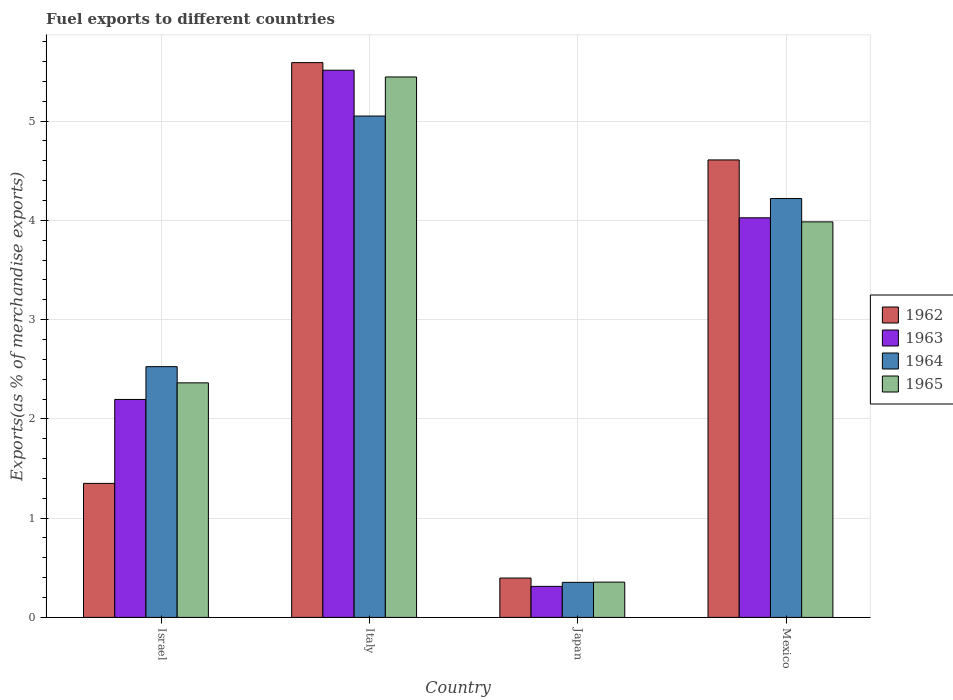Are the number of bars per tick equal to the number of legend labels?
Give a very brief answer. Yes. Are the number of bars on each tick of the X-axis equal?
Offer a very short reply. Yes. How many bars are there on the 1st tick from the left?
Provide a succinct answer. 4. How many bars are there on the 1st tick from the right?
Your answer should be compact. 4. What is the label of the 2nd group of bars from the left?
Give a very brief answer. Italy. What is the percentage of exports to different countries in 1964 in Italy?
Provide a short and direct response. 5.05. Across all countries, what is the maximum percentage of exports to different countries in 1965?
Your answer should be very brief. 5.45. Across all countries, what is the minimum percentage of exports to different countries in 1964?
Keep it short and to the point. 0.35. In which country was the percentage of exports to different countries in 1964 maximum?
Offer a terse response. Italy. In which country was the percentage of exports to different countries in 1963 minimum?
Provide a short and direct response. Japan. What is the total percentage of exports to different countries in 1964 in the graph?
Your response must be concise. 12.15. What is the difference between the percentage of exports to different countries in 1964 in Japan and that in Mexico?
Your response must be concise. -3.87. What is the difference between the percentage of exports to different countries in 1963 in Japan and the percentage of exports to different countries in 1962 in Italy?
Provide a succinct answer. -5.28. What is the average percentage of exports to different countries in 1962 per country?
Make the answer very short. 2.99. What is the difference between the percentage of exports to different countries of/in 1964 and percentage of exports to different countries of/in 1963 in Italy?
Provide a succinct answer. -0.46. What is the ratio of the percentage of exports to different countries in 1964 in Italy to that in Mexico?
Give a very brief answer. 1.2. Is the percentage of exports to different countries in 1963 in Italy less than that in Japan?
Your response must be concise. No. Is the difference between the percentage of exports to different countries in 1964 in Israel and Italy greater than the difference between the percentage of exports to different countries in 1963 in Israel and Italy?
Give a very brief answer. Yes. What is the difference between the highest and the second highest percentage of exports to different countries in 1962?
Your response must be concise. -3.26. What is the difference between the highest and the lowest percentage of exports to different countries in 1965?
Provide a short and direct response. 5.09. Is the sum of the percentage of exports to different countries in 1963 in Israel and Mexico greater than the maximum percentage of exports to different countries in 1962 across all countries?
Make the answer very short. Yes. What does the 2nd bar from the right in Japan represents?
Your response must be concise. 1964. Is it the case that in every country, the sum of the percentage of exports to different countries in 1963 and percentage of exports to different countries in 1962 is greater than the percentage of exports to different countries in 1965?
Give a very brief answer. Yes. Are the values on the major ticks of Y-axis written in scientific E-notation?
Provide a short and direct response. No. Does the graph contain grids?
Provide a succinct answer. Yes. Where does the legend appear in the graph?
Give a very brief answer. Center right. How many legend labels are there?
Your answer should be very brief. 4. How are the legend labels stacked?
Offer a terse response. Vertical. What is the title of the graph?
Offer a terse response. Fuel exports to different countries. Does "1977" appear as one of the legend labels in the graph?
Make the answer very short. No. What is the label or title of the Y-axis?
Make the answer very short. Exports(as % of merchandise exports). What is the Exports(as % of merchandise exports) of 1962 in Israel?
Your response must be concise. 1.35. What is the Exports(as % of merchandise exports) of 1963 in Israel?
Your answer should be compact. 2.2. What is the Exports(as % of merchandise exports) of 1964 in Israel?
Your answer should be very brief. 2.53. What is the Exports(as % of merchandise exports) of 1965 in Israel?
Your answer should be very brief. 2.36. What is the Exports(as % of merchandise exports) in 1962 in Italy?
Provide a succinct answer. 5.59. What is the Exports(as % of merchandise exports) in 1963 in Italy?
Make the answer very short. 5.51. What is the Exports(as % of merchandise exports) in 1964 in Italy?
Make the answer very short. 5.05. What is the Exports(as % of merchandise exports) in 1965 in Italy?
Give a very brief answer. 5.45. What is the Exports(as % of merchandise exports) of 1962 in Japan?
Keep it short and to the point. 0.4. What is the Exports(as % of merchandise exports) of 1963 in Japan?
Ensure brevity in your answer.  0.31. What is the Exports(as % of merchandise exports) of 1964 in Japan?
Make the answer very short. 0.35. What is the Exports(as % of merchandise exports) of 1965 in Japan?
Your answer should be compact. 0.36. What is the Exports(as % of merchandise exports) of 1962 in Mexico?
Give a very brief answer. 4.61. What is the Exports(as % of merchandise exports) of 1963 in Mexico?
Keep it short and to the point. 4.03. What is the Exports(as % of merchandise exports) of 1964 in Mexico?
Offer a very short reply. 4.22. What is the Exports(as % of merchandise exports) of 1965 in Mexico?
Ensure brevity in your answer.  3.99. Across all countries, what is the maximum Exports(as % of merchandise exports) in 1962?
Your response must be concise. 5.59. Across all countries, what is the maximum Exports(as % of merchandise exports) of 1963?
Offer a terse response. 5.51. Across all countries, what is the maximum Exports(as % of merchandise exports) of 1964?
Provide a short and direct response. 5.05. Across all countries, what is the maximum Exports(as % of merchandise exports) in 1965?
Provide a succinct answer. 5.45. Across all countries, what is the minimum Exports(as % of merchandise exports) in 1962?
Your answer should be very brief. 0.4. Across all countries, what is the minimum Exports(as % of merchandise exports) of 1963?
Provide a short and direct response. 0.31. Across all countries, what is the minimum Exports(as % of merchandise exports) of 1964?
Make the answer very short. 0.35. Across all countries, what is the minimum Exports(as % of merchandise exports) of 1965?
Offer a terse response. 0.36. What is the total Exports(as % of merchandise exports) in 1962 in the graph?
Make the answer very short. 11.95. What is the total Exports(as % of merchandise exports) in 1963 in the graph?
Give a very brief answer. 12.05. What is the total Exports(as % of merchandise exports) of 1964 in the graph?
Provide a short and direct response. 12.15. What is the total Exports(as % of merchandise exports) of 1965 in the graph?
Give a very brief answer. 12.15. What is the difference between the Exports(as % of merchandise exports) of 1962 in Israel and that in Italy?
Your answer should be very brief. -4.24. What is the difference between the Exports(as % of merchandise exports) in 1963 in Israel and that in Italy?
Make the answer very short. -3.32. What is the difference between the Exports(as % of merchandise exports) in 1964 in Israel and that in Italy?
Keep it short and to the point. -2.53. What is the difference between the Exports(as % of merchandise exports) in 1965 in Israel and that in Italy?
Ensure brevity in your answer.  -3.08. What is the difference between the Exports(as % of merchandise exports) of 1962 in Israel and that in Japan?
Your response must be concise. 0.95. What is the difference between the Exports(as % of merchandise exports) of 1963 in Israel and that in Japan?
Offer a terse response. 1.88. What is the difference between the Exports(as % of merchandise exports) of 1964 in Israel and that in Japan?
Your answer should be compact. 2.17. What is the difference between the Exports(as % of merchandise exports) of 1965 in Israel and that in Japan?
Your answer should be very brief. 2.01. What is the difference between the Exports(as % of merchandise exports) in 1962 in Israel and that in Mexico?
Ensure brevity in your answer.  -3.26. What is the difference between the Exports(as % of merchandise exports) of 1963 in Israel and that in Mexico?
Your answer should be compact. -1.83. What is the difference between the Exports(as % of merchandise exports) in 1964 in Israel and that in Mexico?
Give a very brief answer. -1.69. What is the difference between the Exports(as % of merchandise exports) in 1965 in Israel and that in Mexico?
Provide a short and direct response. -1.62. What is the difference between the Exports(as % of merchandise exports) in 1962 in Italy and that in Japan?
Make the answer very short. 5.19. What is the difference between the Exports(as % of merchandise exports) of 1963 in Italy and that in Japan?
Your answer should be compact. 5.2. What is the difference between the Exports(as % of merchandise exports) in 1964 in Italy and that in Japan?
Make the answer very short. 4.7. What is the difference between the Exports(as % of merchandise exports) of 1965 in Italy and that in Japan?
Your answer should be very brief. 5.09. What is the difference between the Exports(as % of merchandise exports) in 1962 in Italy and that in Mexico?
Offer a very short reply. 0.98. What is the difference between the Exports(as % of merchandise exports) in 1963 in Italy and that in Mexico?
Provide a short and direct response. 1.49. What is the difference between the Exports(as % of merchandise exports) in 1964 in Italy and that in Mexico?
Ensure brevity in your answer.  0.83. What is the difference between the Exports(as % of merchandise exports) in 1965 in Italy and that in Mexico?
Give a very brief answer. 1.46. What is the difference between the Exports(as % of merchandise exports) of 1962 in Japan and that in Mexico?
Provide a succinct answer. -4.21. What is the difference between the Exports(as % of merchandise exports) in 1963 in Japan and that in Mexico?
Offer a terse response. -3.71. What is the difference between the Exports(as % of merchandise exports) of 1964 in Japan and that in Mexico?
Your answer should be very brief. -3.87. What is the difference between the Exports(as % of merchandise exports) of 1965 in Japan and that in Mexico?
Keep it short and to the point. -3.63. What is the difference between the Exports(as % of merchandise exports) in 1962 in Israel and the Exports(as % of merchandise exports) in 1963 in Italy?
Offer a very short reply. -4.16. What is the difference between the Exports(as % of merchandise exports) of 1962 in Israel and the Exports(as % of merchandise exports) of 1964 in Italy?
Your answer should be compact. -3.7. What is the difference between the Exports(as % of merchandise exports) of 1962 in Israel and the Exports(as % of merchandise exports) of 1965 in Italy?
Provide a short and direct response. -4.09. What is the difference between the Exports(as % of merchandise exports) of 1963 in Israel and the Exports(as % of merchandise exports) of 1964 in Italy?
Offer a terse response. -2.86. What is the difference between the Exports(as % of merchandise exports) of 1963 in Israel and the Exports(as % of merchandise exports) of 1965 in Italy?
Your answer should be very brief. -3.25. What is the difference between the Exports(as % of merchandise exports) of 1964 in Israel and the Exports(as % of merchandise exports) of 1965 in Italy?
Your answer should be compact. -2.92. What is the difference between the Exports(as % of merchandise exports) of 1962 in Israel and the Exports(as % of merchandise exports) of 1963 in Japan?
Offer a terse response. 1.04. What is the difference between the Exports(as % of merchandise exports) in 1962 in Israel and the Exports(as % of merchandise exports) in 1964 in Japan?
Offer a very short reply. 1. What is the difference between the Exports(as % of merchandise exports) of 1962 in Israel and the Exports(as % of merchandise exports) of 1965 in Japan?
Give a very brief answer. 0.99. What is the difference between the Exports(as % of merchandise exports) in 1963 in Israel and the Exports(as % of merchandise exports) in 1964 in Japan?
Offer a very short reply. 1.84. What is the difference between the Exports(as % of merchandise exports) in 1963 in Israel and the Exports(as % of merchandise exports) in 1965 in Japan?
Give a very brief answer. 1.84. What is the difference between the Exports(as % of merchandise exports) in 1964 in Israel and the Exports(as % of merchandise exports) in 1965 in Japan?
Your answer should be compact. 2.17. What is the difference between the Exports(as % of merchandise exports) in 1962 in Israel and the Exports(as % of merchandise exports) in 1963 in Mexico?
Your answer should be very brief. -2.68. What is the difference between the Exports(as % of merchandise exports) in 1962 in Israel and the Exports(as % of merchandise exports) in 1964 in Mexico?
Make the answer very short. -2.87. What is the difference between the Exports(as % of merchandise exports) in 1962 in Israel and the Exports(as % of merchandise exports) in 1965 in Mexico?
Provide a short and direct response. -2.63. What is the difference between the Exports(as % of merchandise exports) of 1963 in Israel and the Exports(as % of merchandise exports) of 1964 in Mexico?
Your answer should be very brief. -2.02. What is the difference between the Exports(as % of merchandise exports) of 1963 in Israel and the Exports(as % of merchandise exports) of 1965 in Mexico?
Your answer should be very brief. -1.79. What is the difference between the Exports(as % of merchandise exports) in 1964 in Israel and the Exports(as % of merchandise exports) in 1965 in Mexico?
Your response must be concise. -1.46. What is the difference between the Exports(as % of merchandise exports) in 1962 in Italy and the Exports(as % of merchandise exports) in 1963 in Japan?
Provide a succinct answer. 5.28. What is the difference between the Exports(as % of merchandise exports) of 1962 in Italy and the Exports(as % of merchandise exports) of 1964 in Japan?
Your response must be concise. 5.24. What is the difference between the Exports(as % of merchandise exports) in 1962 in Italy and the Exports(as % of merchandise exports) in 1965 in Japan?
Offer a very short reply. 5.23. What is the difference between the Exports(as % of merchandise exports) of 1963 in Italy and the Exports(as % of merchandise exports) of 1964 in Japan?
Provide a short and direct response. 5.16. What is the difference between the Exports(as % of merchandise exports) in 1963 in Italy and the Exports(as % of merchandise exports) in 1965 in Japan?
Give a very brief answer. 5.16. What is the difference between the Exports(as % of merchandise exports) in 1964 in Italy and the Exports(as % of merchandise exports) in 1965 in Japan?
Ensure brevity in your answer.  4.7. What is the difference between the Exports(as % of merchandise exports) in 1962 in Italy and the Exports(as % of merchandise exports) in 1963 in Mexico?
Offer a terse response. 1.56. What is the difference between the Exports(as % of merchandise exports) in 1962 in Italy and the Exports(as % of merchandise exports) in 1964 in Mexico?
Your answer should be very brief. 1.37. What is the difference between the Exports(as % of merchandise exports) of 1962 in Italy and the Exports(as % of merchandise exports) of 1965 in Mexico?
Ensure brevity in your answer.  1.6. What is the difference between the Exports(as % of merchandise exports) of 1963 in Italy and the Exports(as % of merchandise exports) of 1964 in Mexico?
Provide a succinct answer. 1.29. What is the difference between the Exports(as % of merchandise exports) of 1963 in Italy and the Exports(as % of merchandise exports) of 1965 in Mexico?
Provide a short and direct response. 1.53. What is the difference between the Exports(as % of merchandise exports) in 1964 in Italy and the Exports(as % of merchandise exports) in 1965 in Mexico?
Give a very brief answer. 1.07. What is the difference between the Exports(as % of merchandise exports) in 1962 in Japan and the Exports(as % of merchandise exports) in 1963 in Mexico?
Offer a very short reply. -3.63. What is the difference between the Exports(as % of merchandise exports) of 1962 in Japan and the Exports(as % of merchandise exports) of 1964 in Mexico?
Your response must be concise. -3.82. What is the difference between the Exports(as % of merchandise exports) in 1962 in Japan and the Exports(as % of merchandise exports) in 1965 in Mexico?
Offer a terse response. -3.59. What is the difference between the Exports(as % of merchandise exports) of 1963 in Japan and the Exports(as % of merchandise exports) of 1964 in Mexico?
Provide a short and direct response. -3.91. What is the difference between the Exports(as % of merchandise exports) of 1963 in Japan and the Exports(as % of merchandise exports) of 1965 in Mexico?
Your answer should be very brief. -3.67. What is the difference between the Exports(as % of merchandise exports) of 1964 in Japan and the Exports(as % of merchandise exports) of 1965 in Mexico?
Provide a short and direct response. -3.63. What is the average Exports(as % of merchandise exports) in 1962 per country?
Ensure brevity in your answer.  2.99. What is the average Exports(as % of merchandise exports) of 1963 per country?
Make the answer very short. 3.01. What is the average Exports(as % of merchandise exports) of 1964 per country?
Your answer should be compact. 3.04. What is the average Exports(as % of merchandise exports) of 1965 per country?
Your answer should be very brief. 3.04. What is the difference between the Exports(as % of merchandise exports) of 1962 and Exports(as % of merchandise exports) of 1963 in Israel?
Offer a very short reply. -0.85. What is the difference between the Exports(as % of merchandise exports) of 1962 and Exports(as % of merchandise exports) of 1964 in Israel?
Provide a short and direct response. -1.18. What is the difference between the Exports(as % of merchandise exports) in 1962 and Exports(as % of merchandise exports) in 1965 in Israel?
Offer a terse response. -1.01. What is the difference between the Exports(as % of merchandise exports) in 1963 and Exports(as % of merchandise exports) in 1964 in Israel?
Provide a short and direct response. -0.33. What is the difference between the Exports(as % of merchandise exports) in 1963 and Exports(as % of merchandise exports) in 1965 in Israel?
Keep it short and to the point. -0.17. What is the difference between the Exports(as % of merchandise exports) in 1964 and Exports(as % of merchandise exports) in 1965 in Israel?
Ensure brevity in your answer.  0.16. What is the difference between the Exports(as % of merchandise exports) in 1962 and Exports(as % of merchandise exports) in 1963 in Italy?
Your answer should be very brief. 0.08. What is the difference between the Exports(as % of merchandise exports) of 1962 and Exports(as % of merchandise exports) of 1964 in Italy?
Provide a short and direct response. 0.54. What is the difference between the Exports(as % of merchandise exports) in 1962 and Exports(as % of merchandise exports) in 1965 in Italy?
Your answer should be very brief. 0.14. What is the difference between the Exports(as % of merchandise exports) of 1963 and Exports(as % of merchandise exports) of 1964 in Italy?
Provide a succinct answer. 0.46. What is the difference between the Exports(as % of merchandise exports) in 1963 and Exports(as % of merchandise exports) in 1965 in Italy?
Keep it short and to the point. 0.07. What is the difference between the Exports(as % of merchandise exports) in 1964 and Exports(as % of merchandise exports) in 1965 in Italy?
Provide a short and direct response. -0.39. What is the difference between the Exports(as % of merchandise exports) of 1962 and Exports(as % of merchandise exports) of 1963 in Japan?
Keep it short and to the point. 0.08. What is the difference between the Exports(as % of merchandise exports) of 1962 and Exports(as % of merchandise exports) of 1964 in Japan?
Keep it short and to the point. 0.04. What is the difference between the Exports(as % of merchandise exports) in 1962 and Exports(as % of merchandise exports) in 1965 in Japan?
Your answer should be very brief. 0.04. What is the difference between the Exports(as % of merchandise exports) in 1963 and Exports(as % of merchandise exports) in 1964 in Japan?
Keep it short and to the point. -0.04. What is the difference between the Exports(as % of merchandise exports) in 1963 and Exports(as % of merchandise exports) in 1965 in Japan?
Offer a terse response. -0.04. What is the difference between the Exports(as % of merchandise exports) of 1964 and Exports(as % of merchandise exports) of 1965 in Japan?
Make the answer very short. -0. What is the difference between the Exports(as % of merchandise exports) in 1962 and Exports(as % of merchandise exports) in 1963 in Mexico?
Your answer should be compact. 0.58. What is the difference between the Exports(as % of merchandise exports) in 1962 and Exports(as % of merchandise exports) in 1964 in Mexico?
Your answer should be very brief. 0.39. What is the difference between the Exports(as % of merchandise exports) of 1962 and Exports(as % of merchandise exports) of 1965 in Mexico?
Provide a succinct answer. 0.62. What is the difference between the Exports(as % of merchandise exports) in 1963 and Exports(as % of merchandise exports) in 1964 in Mexico?
Make the answer very short. -0.19. What is the difference between the Exports(as % of merchandise exports) in 1963 and Exports(as % of merchandise exports) in 1965 in Mexico?
Your answer should be very brief. 0.04. What is the difference between the Exports(as % of merchandise exports) of 1964 and Exports(as % of merchandise exports) of 1965 in Mexico?
Make the answer very short. 0.23. What is the ratio of the Exports(as % of merchandise exports) of 1962 in Israel to that in Italy?
Make the answer very short. 0.24. What is the ratio of the Exports(as % of merchandise exports) of 1963 in Israel to that in Italy?
Your response must be concise. 0.4. What is the ratio of the Exports(as % of merchandise exports) in 1964 in Israel to that in Italy?
Provide a short and direct response. 0.5. What is the ratio of the Exports(as % of merchandise exports) in 1965 in Israel to that in Italy?
Your answer should be very brief. 0.43. What is the ratio of the Exports(as % of merchandise exports) of 1962 in Israel to that in Japan?
Keep it short and to the point. 3.4. What is the ratio of the Exports(as % of merchandise exports) in 1963 in Israel to that in Japan?
Your answer should be compact. 7.03. What is the ratio of the Exports(as % of merchandise exports) of 1964 in Israel to that in Japan?
Your answer should be very brief. 7.16. What is the ratio of the Exports(as % of merchandise exports) of 1965 in Israel to that in Japan?
Your answer should be very brief. 6.65. What is the ratio of the Exports(as % of merchandise exports) of 1962 in Israel to that in Mexico?
Provide a short and direct response. 0.29. What is the ratio of the Exports(as % of merchandise exports) of 1963 in Israel to that in Mexico?
Ensure brevity in your answer.  0.55. What is the ratio of the Exports(as % of merchandise exports) of 1964 in Israel to that in Mexico?
Keep it short and to the point. 0.6. What is the ratio of the Exports(as % of merchandise exports) of 1965 in Israel to that in Mexico?
Ensure brevity in your answer.  0.59. What is the ratio of the Exports(as % of merchandise exports) of 1962 in Italy to that in Japan?
Give a very brief answer. 14.1. What is the ratio of the Exports(as % of merchandise exports) in 1963 in Italy to that in Japan?
Keep it short and to the point. 17.64. What is the ratio of the Exports(as % of merchandise exports) of 1964 in Italy to that in Japan?
Provide a short and direct response. 14.31. What is the ratio of the Exports(as % of merchandise exports) of 1965 in Italy to that in Japan?
Your response must be concise. 15.32. What is the ratio of the Exports(as % of merchandise exports) of 1962 in Italy to that in Mexico?
Your answer should be very brief. 1.21. What is the ratio of the Exports(as % of merchandise exports) of 1963 in Italy to that in Mexico?
Your answer should be compact. 1.37. What is the ratio of the Exports(as % of merchandise exports) of 1964 in Italy to that in Mexico?
Your answer should be very brief. 1.2. What is the ratio of the Exports(as % of merchandise exports) in 1965 in Italy to that in Mexico?
Give a very brief answer. 1.37. What is the ratio of the Exports(as % of merchandise exports) in 1962 in Japan to that in Mexico?
Provide a succinct answer. 0.09. What is the ratio of the Exports(as % of merchandise exports) of 1963 in Japan to that in Mexico?
Your answer should be very brief. 0.08. What is the ratio of the Exports(as % of merchandise exports) in 1964 in Japan to that in Mexico?
Your answer should be very brief. 0.08. What is the ratio of the Exports(as % of merchandise exports) of 1965 in Japan to that in Mexico?
Your response must be concise. 0.09. What is the difference between the highest and the second highest Exports(as % of merchandise exports) in 1962?
Give a very brief answer. 0.98. What is the difference between the highest and the second highest Exports(as % of merchandise exports) of 1963?
Provide a succinct answer. 1.49. What is the difference between the highest and the second highest Exports(as % of merchandise exports) of 1964?
Your response must be concise. 0.83. What is the difference between the highest and the second highest Exports(as % of merchandise exports) in 1965?
Your response must be concise. 1.46. What is the difference between the highest and the lowest Exports(as % of merchandise exports) in 1962?
Provide a succinct answer. 5.19. What is the difference between the highest and the lowest Exports(as % of merchandise exports) of 1963?
Provide a succinct answer. 5.2. What is the difference between the highest and the lowest Exports(as % of merchandise exports) of 1964?
Keep it short and to the point. 4.7. What is the difference between the highest and the lowest Exports(as % of merchandise exports) in 1965?
Offer a terse response. 5.09. 